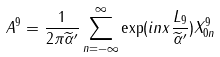Convert formula to latex. <formula><loc_0><loc_0><loc_500><loc_500>A ^ { 9 } = \frac { 1 } { 2 \pi \widetilde { \alpha } ^ { \prime } } \sum _ { n = - \infty } ^ { \infty } \exp ( i n x \frac { L _ { 9 } } { \widetilde { \alpha } ^ { \prime } } ) X _ { 0 n } ^ { 9 }</formula> 